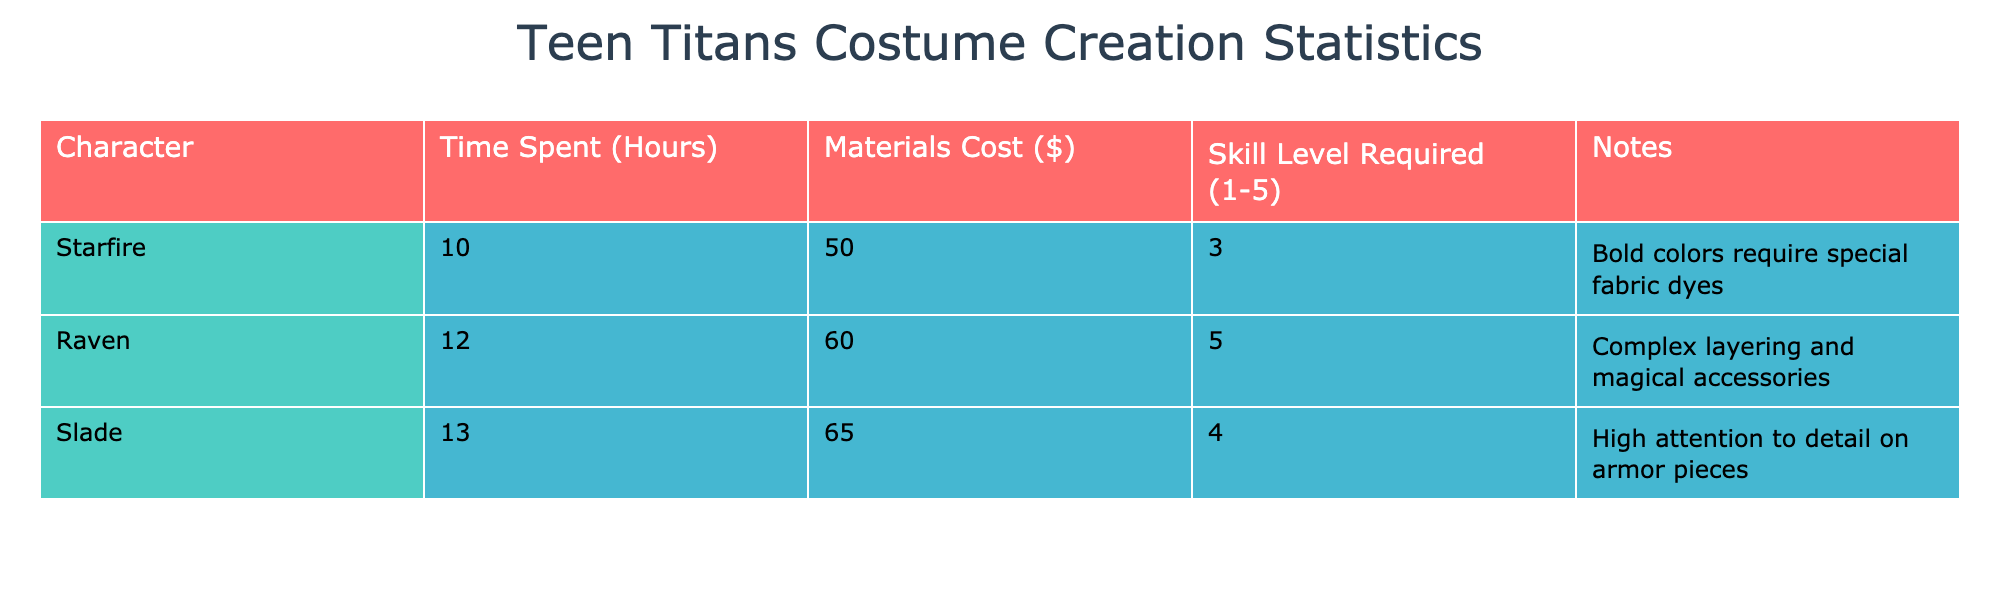What is the total time spent on creating the costumes for all characters? To find the total time, add the time spent on each character's costume: 10 (Starfire) + 12 (Raven) + 13 (Slade) = 35 hours.
Answer: 35 hours Which character requires the highest skill level for their costume? The character with the highest skill level is Raven, who has a skill level of 5.
Answer: Raven What is the average materials cost for creating a Teen Titans costume? To find the average materials cost, sum the materials cost for all characters (50 + 60 + 65 = 175) and divide by the number of characters (3): 175/3 = approximately 58.33.
Answer: 58.33 Is the time spent on Slade's costume more than the average time spent on all costumes? The average time spent is calculated as (10 + 12 + 13)/3 = 11.67. Since Slade's time is 13, it is greater.
Answer: Yes What is the difference in materials cost between Raven and Starfire? The materials cost for Raven is 60, and for Starfire, it is 50. Therefore, the difference is 60 - 50 = 10.
Answer: 10 Which character has a note related to the complexity of the costume design? The note for Raven mentions "Complex layering and magical accessories," indicating that her costume requires more intricate design details.
Answer: Raven What character's costume takes the least time to create? The character with the least time spent is Starfire, at 10 hours.
Answer: Starfire What is the total materials cost for all three costumes combined? To find the total materials cost, add the individual costs: 50 (Starfire) + 60 (Raven) + 65 (Slade) = 175.
Answer: 175 Is there a character that requires a skill level of 4? Yes, Slade has a skill level of 4.
Answer: Yes 